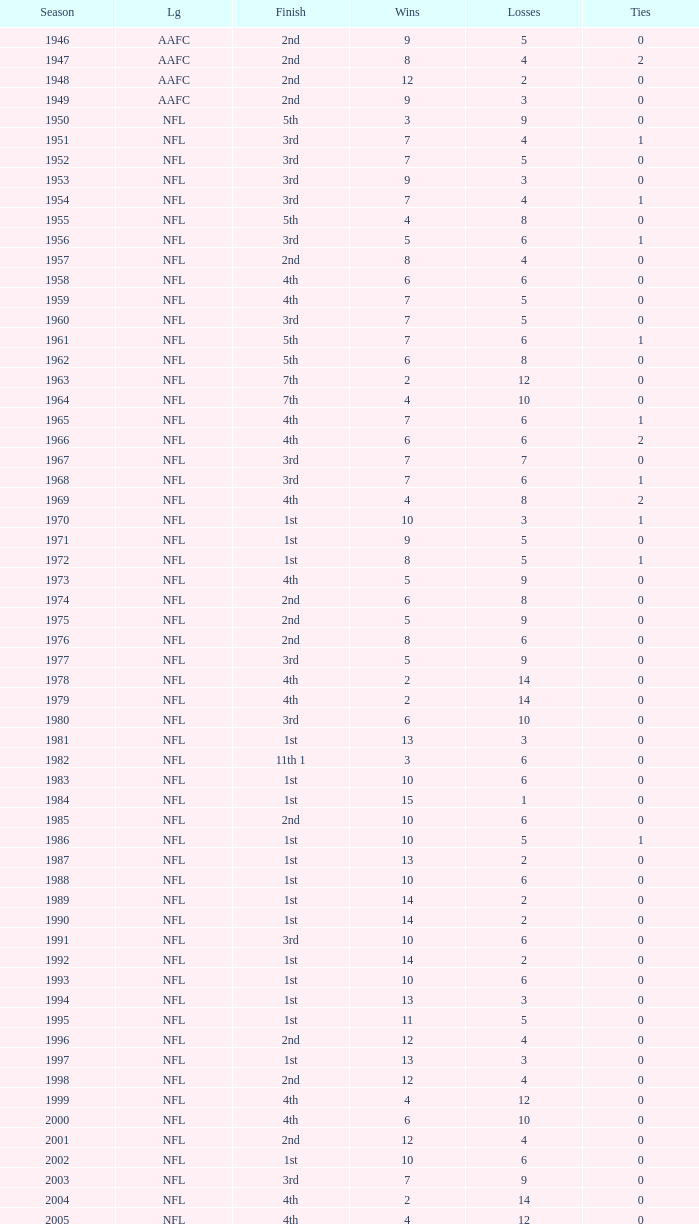Write the full table. {'header': ['Season', 'Lg', 'Finish', 'Wins', 'Losses', 'Ties'], 'rows': [['1946', 'AAFC', '2nd', '9', '5', '0'], ['1947', 'AAFC', '2nd', '8', '4', '2'], ['1948', 'AAFC', '2nd', '12', '2', '0'], ['1949', 'AAFC', '2nd', '9', '3', '0'], ['1950', 'NFL', '5th', '3', '9', '0'], ['1951', 'NFL', '3rd', '7', '4', '1'], ['1952', 'NFL', '3rd', '7', '5', '0'], ['1953', 'NFL', '3rd', '9', '3', '0'], ['1954', 'NFL', '3rd', '7', '4', '1'], ['1955', 'NFL', '5th', '4', '8', '0'], ['1956', 'NFL', '3rd', '5', '6', '1'], ['1957', 'NFL', '2nd', '8', '4', '0'], ['1958', 'NFL', '4th', '6', '6', '0'], ['1959', 'NFL', '4th', '7', '5', '0'], ['1960', 'NFL', '3rd', '7', '5', '0'], ['1961', 'NFL', '5th', '7', '6', '1'], ['1962', 'NFL', '5th', '6', '8', '0'], ['1963', 'NFL', '7th', '2', '12', '0'], ['1964', 'NFL', '7th', '4', '10', '0'], ['1965', 'NFL', '4th', '7', '6', '1'], ['1966', 'NFL', '4th', '6', '6', '2'], ['1967', 'NFL', '3rd', '7', '7', '0'], ['1968', 'NFL', '3rd', '7', '6', '1'], ['1969', 'NFL', '4th', '4', '8', '2'], ['1970', 'NFL', '1st', '10', '3', '1'], ['1971', 'NFL', '1st', '9', '5', '0'], ['1972', 'NFL', '1st', '8', '5', '1'], ['1973', 'NFL', '4th', '5', '9', '0'], ['1974', 'NFL', '2nd', '6', '8', '0'], ['1975', 'NFL', '2nd', '5', '9', '0'], ['1976', 'NFL', '2nd', '8', '6', '0'], ['1977', 'NFL', '3rd', '5', '9', '0'], ['1978', 'NFL', '4th', '2', '14', '0'], ['1979', 'NFL', '4th', '2', '14', '0'], ['1980', 'NFL', '3rd', '6', '10', '0'], ['1981', 'NFL', '1st', '13', '3', '0'], ['1982', 'NFL', '11th 1', '3', '6', '0'], ['1983', 'NFL', '1st', '10', '6', '0'], ['1984', 'NFL', '1st', '15', '1', '0'], ['1985', 'NFL', '2nd', '10', '6', '0'], ['1986', 'NFL', '1st', '10', '5', '1'], ['1987', 'NFL', '1st', '13', '2', '0'], ['1988', 'NFL', '1st', '10', '6', '0'], ['1989', 'NFL', '1st', '14', '2', '0'], ['1990', 'NFL', '1st', '14', '2', '0'], ['1991', 'NFL', '3rd', '10', '6', '0'], ['1992', 'NFL', '1st', '14', '2', '0'], ['1993', 'NFL', '1st', '10', '6', '0'], ['1994', 'NFL', '1st', '13', '3', '0'], ['1995', 'NFL', '1st', '11', '5', '0'], ['1996', 'NFL', '2nd', '12', '4', '0'], ['1997', 'NFL', '1st', '13', '3', '0'], ['1998', 'NFL', '2nd', '12', '4', '0'], ['1999', 'NFL', '4th', '4', '12', '0'], ['2000', 'NFL', '4th', '6', '10', '0'], ['2001', 'NFL', '2nd', '12', '4', '0'], ['2002', 'NFL', '1st', '10', '6', '0'], ['2003', 'NFL', '3rd', '7', '9', '0'], ['2004', 'NFL', '4th', '2', '14', '0'], ['2005', 'NFL', '4th', '4', '12', '0'], ['2006', 'NFL', '3rd', '7', '9', '0'], ['2007', 'NFL', '3rd', '5', '11', '0'], ['2008', 'NFL', '2nd', '7', '9', '0'], ['2009', 'NFL', '2nd', '8', '8', '0'], ['2010', 'NFL', '3rd', '6', '10', '0'], ['2011', 'NFL', '1st', '13', '3', '0'], ['2012', 'NFL', '1st', '11', '4', '1'], ['2013', 'NFL', '2nd', '6', '2', '0']]} What is the losses in the NFL in the 2011 season with less than 13 wins? None. 